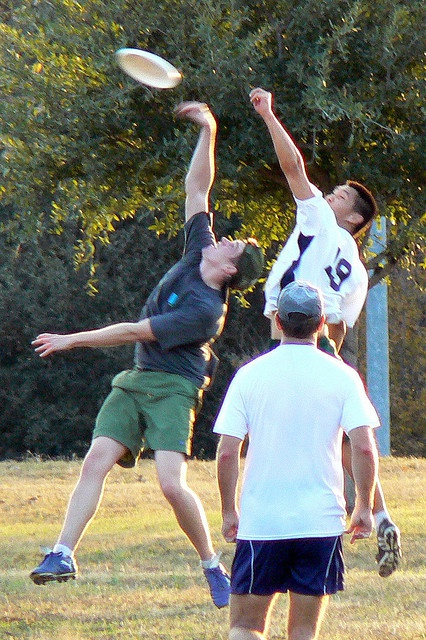Describe the objects in this image and their specific colors. I can see people in darkgreen, black, gray, darkgray, and blue tones, people in darkgreen, lightblue, black, and gray tones, people in darkgreen, lightblue, darkgray, brown, and black tones, and frisbee in darkgreen, ivory, tan, and darkgray tones in this image. 